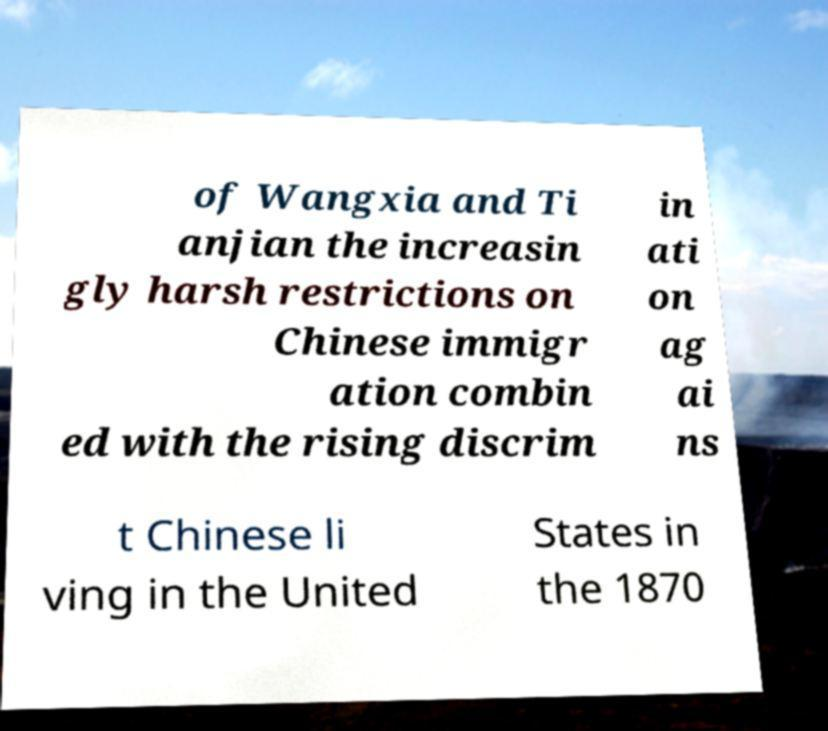Please read and relay the text visible in this image. What does it say? of Wangxia and Ti anjian the increasin gly harsh restrictions on Chinese immigr ation combin ed with the rising discrim in ati on ag ai ns t Chinese li ving in the United States in the 1870 